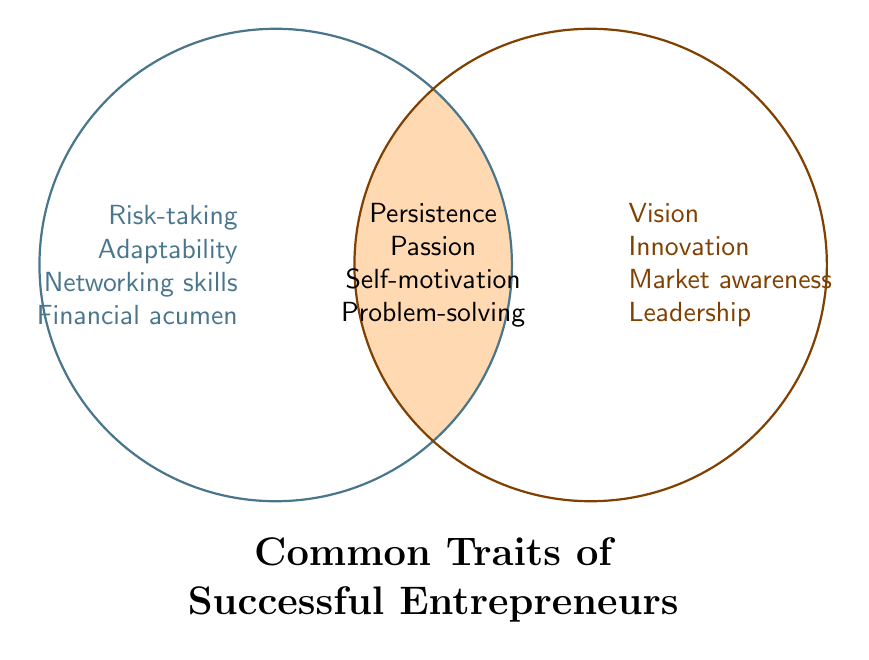What is the title of the figure? The title is located at the bottom of the diagram in large, bold text. It reads "Common Traits of Successful Entrepreneurs".
Answer: Common Traits of Successful Entrepreneurs What traits are exclusive to Set A? The traits exclusive to Set A are listed to the left side of the Venn Diagram in cyan color. These traits are Risk-taking, Adaptability, Networking skills, and Financial acumen.
Answer: Risk-taking, Adaptability, Networking skills, Financial acumen What traits are unique to Set B? The traits exclusive to Set B are listed to the right side of the Venn Diagram in orange color. These traits are Vision, Innovation, Market awareness, and Leadership.
Answer: Vision, Innovation, Market awareness, Leadership Which traits are common to both Set A and Set B? The common traits are located in the intersection area where both circles overlap and include Persistence, Passion, Self-motivation, and Problem-solving.
Answer: Persistence, Passion, Self-motivation, Problem-solving How many traits in total are represented in Set A? Count the traits listed in the cyan-colored section under Set A and those in the intersection. These are Risk-taking, Adaptability, Networking skills, Financial acumen, Persistence, Passion, Self-motivation, Problem-solving, making a total of 8 traits.
Answer: 8 How many traits are only found in Set B and not in Set A? Focus only on the traits listed in the orange-colored section under Set B that are not in the intersection. These traits are Vision, Innovation, Market awareness, and Leadership, making a total of 4.
Answer: 4 Comparing Set A and Set B, which has more unique traits? Set A has 4 unique traits, while Set B also has 4 unique traits. Therefore, both sets have the same number of unique traits.
Answer: Neither, they have the same number of unique traits Are there more traits in the intersection or in the exclusive parts of Set B? There are 4 traits in the intersection (Persistence, Passion, Self-motivation, Problem-solving) and 4 traits exclusive to Set B (Vision, Innovation, Market awareness, Leadership). Thus, they are equal in number.
Answer: Equal Considering the intersection, which trait from Set A is also shared by Set B? The intersection lists the traits common to both sets, which are all shared by both. The traits Persistence, Passion, Self-motivation, and Problem-solving from Set A are also found in Set B. However, no single trait from Set A is specified to be shared apart from these common ones.
Answer: Persistence, Passion, Self-motivation, and Problem-solving Count all traits across Set A, Set B, and their intersection. What is the total number of distinct traits? Add the unique traits of Set A (4), the unique traits of Set B (4), and the traits in the intersection (4). The total number of distinct traits is 4 + 4 + 4 = 12.
Answer: 12 